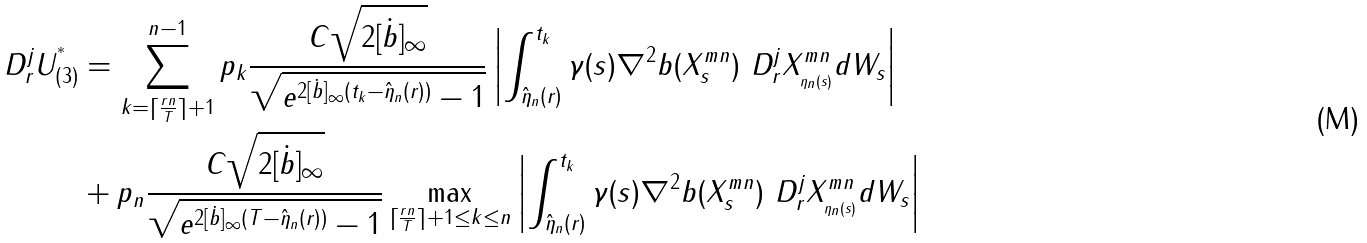Convert formula to latex. <formula><loc_0><loc_0><loc_500><loc_500>\ D ^ { j } _ { r } U _ { ( 3 ) } ^ { ^ { * } } & = \sum _ { k = { \lceil \frac { r n } { T } \rceil } + 1 } ^ { n - 1 } p _ { k } \frac { C \sqrt { 2 [ \dot { b } ] _ { \infty } } } { \sqrt { e ^ { 2 [ \dot { b } ] _ { \infty } ( t _ { k } - \hat { \eta } _ { n } ( r ) ) } - 1 } } \left | \int _ { { \hat { \eta } _ { n } ( r ) } } ^ { t _ { k } } \gamma ( s ) \nabla ^ { 2 } b ( X ^ { m n } _ { s } ) \ D ^ { j } _ { r } X ^ { m n } _ { { _ { \eta _ { n } ( s ) } } } d W _ { s } \right | \\ & + p _ { n } \frac { C \sqrt { 2 [ \dot { b } ] _ { \infty } } } { \sqrt { e ^ { 2 [ \dot { b } ] _ { \infty } ( T - \hat { \eta } _ { n } ( r ) ) } - 1 } } \max _ { { \lceil \frac { r n } { T } \rceil + 1 } \leq k \leq n } \left | \int _ { { \hat { \eta } _ { n } ( r ) } } ^ { t _ { k } } \gamma ( s ) \nabla ^ { 2 } b ( X ^ { m n } _ { s } ) \ D ^ { j } _ { r } X ^ { m n } _ { { _ { \eta _ { n } ( s ) } } } d W _ { s } \right |</formula> 